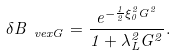<formula> <loc_0><loc_0><loc_500><loc_500>\delta B _ { \ v e x G } = \frac { e ^ { - \frac { 1 } { 2 } \xi _ { 0 } ^ { 2 } G ^ { 2 } } } { 1 + \lambda _ { L } ^ { 2 } G ^ { 2 } } .</formula> 